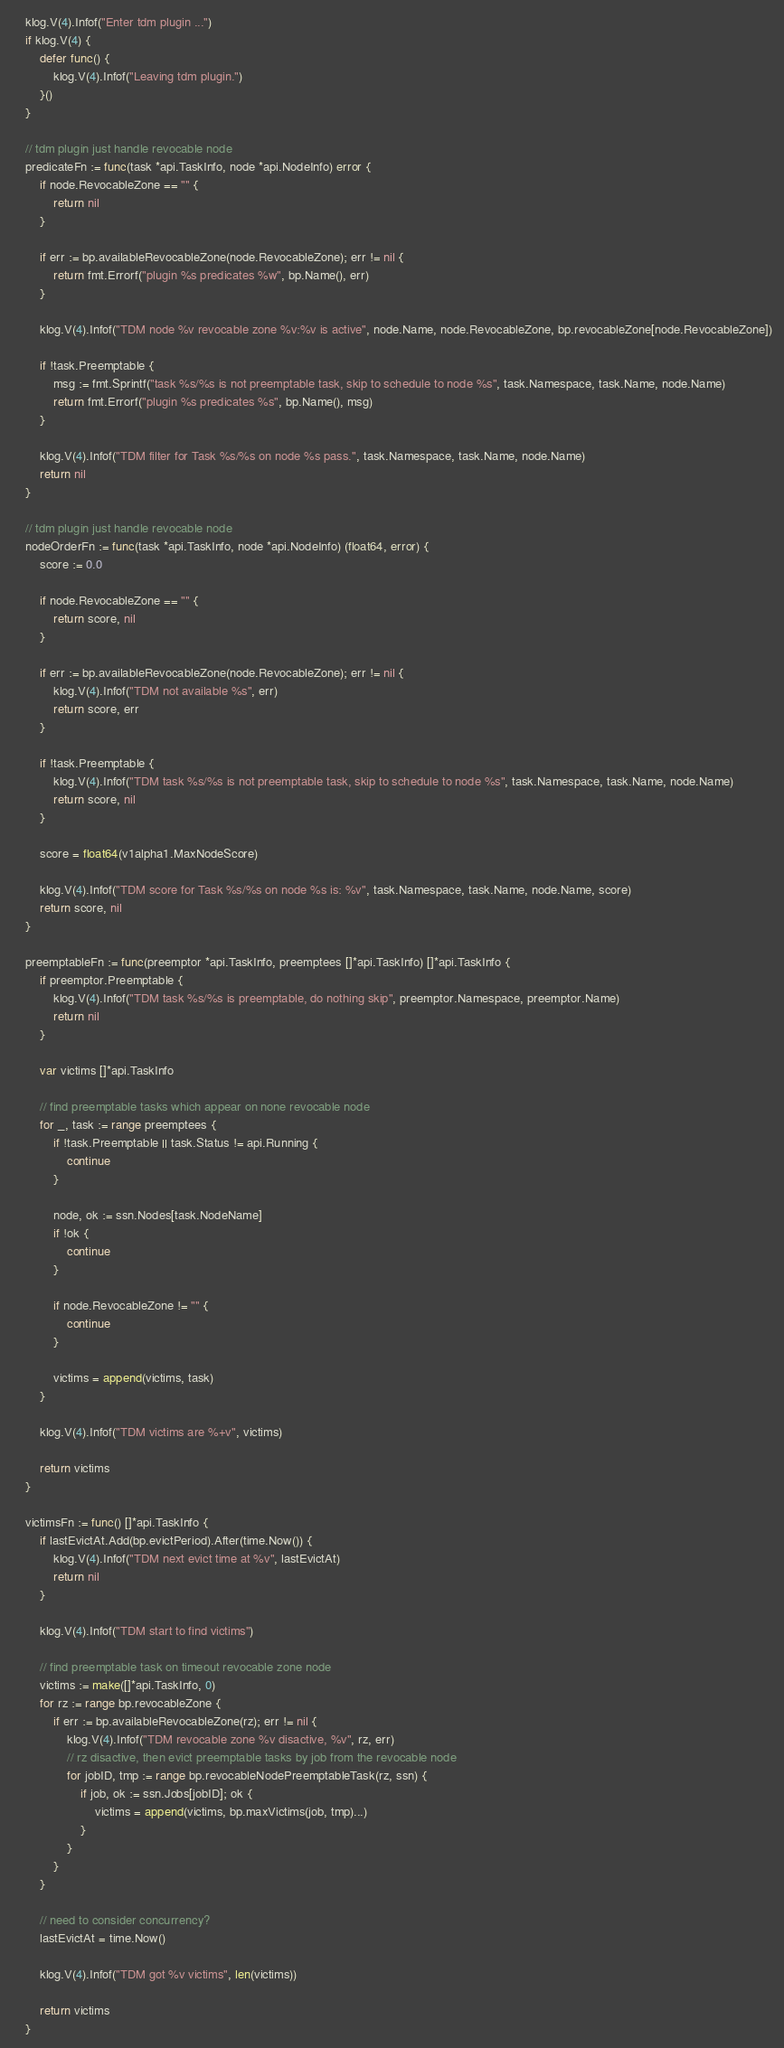Convert code to text. <code><loc_0><loc_0><loc_500><loc_500><_Go_>	klog.V(4).Infof("Enter tdm plugin ...")
	if klog.V(4) {
		defer func() {
			klog.V(4).Infof("Leaving tdm plugin.")
		}()
	}

	// tdm plugin just handle revocable node
	predicateFn := func(task *api.TaskInfo, node *api.NodeInfo) error {
		if node.RevocableZone == "" {
			return nil
		}

		if err := bp.availableRevocableZone(node.RevocableZone); err != nil {
			return fmt.Errorf("plugin %s predicates %w", bp.Name(), err)
		}

		klog.V(4).Infof("TDM node %v revocable zone %v:%v is active", node.Name, node.RevocableZone, bp.revocableZone[node.RevocableZone])

		if !task.Preemptable {
			msg := fmt.Sprintf("task %s/%s is not preemptable task, skip to schedule to node %s", task.Namespace, task.Name, node.Name)
			return fmt.Errorf("plugin %s predicates %s", bp.Name(), msg)
		}

		klog.V(4).Infof("TDM filter for Task %s/%s on node %s pass.", task.Namespace, task.Name, node.Name)
		return nil
	}

	// tdm plugin just handle revocable node
	nodeOrderFn := func(task *api.TaskInfo, node *api.NodeInfo) (float64, error) {
		score := 0.0

		if node.RevocableZone == "" {
			return score, nil
		}

		if err := bp.availableRevocableZone(node.RevocableZone); err != nil {
			klog.V(4).Infof("TDM not available %s", err)
			return score, err
		}

		if !task.Preemptable {
			klog.V(4).Infof("TDM task %s/%s is not preemptable task, skip to schedule to node %s", task.Namespace, task.Name, node.Name)
			return score, nil
		}

		score = float64(v1alpha1.MaxNodeScore)

		klog.V(4).Infof("TDM score for Task %s/%s on node %s is: %v", task.Namespace, task.Name, node.Name, score)
		return score, nil
	}

	preemptableFn := func(preemptor *api.TaskInfo, preemptees []*api.TaskInfo) []*api.TaskInfo {
		if preemptor.Preemptable {
			klog.V(4).Infof("TDM task %s/%s is preemptable, do nothing skip", preemptor.Namespace, preemptor.Name)
			return nil
		}

		var victims []*api.TaskInfo

		// find preemptable tasks which appear on none revocable node
		for _, task := range preemptees {
			if !task.Preemptable || task.Status != api.Running {
				continue
			}

			node, ok := ssn.Nodes[task.NodeName]
			if !ok {
				continue
			}

			if node.RevocableZone != "" {
				continue
			}

			victims = append(victims, task)
		}

		klog.V(4).Infof("TDM victims are %+v", victims)

		return victims
	}

	victimsFn := func() []*api.TaskInfo {
		if lastEvictAt.Add(bp.evictPeriod).After(time.Now()) {
			klog.V(4).Infof("TDM next evict time at %v", lastEvictAt)
			return nil
		}

		klog.V(4).Infof("TDM start to find victims")

		// find preemptable task on timeout revocable zone node
		victims := make([]*api.TaskInfo, 0)
		for rz := range bp.revocableZone {
			if err := bp.availableRevocableZone(rz); err != nil {
				klog.V(4).Infof("TDM revocable zone %v disactive, %v", rz, err)
				// rz disactive, then evict preemptable tasks by job from the revocable node
				for jobID, tmp := range bp.revocableNodePreemptableTask(rz, ssn) {
					if job, ok := ssn.Jobs[jobID]; ok {
						victims = append(victims, bp.maxVictims(job, tmp)...)
					}
				}
			}
		}

		// need to consider concurrency?
		lastEvictAt = time.Now()

		klog.V(4).Infof("TDM got %v victims", len(victims))

		return victims
	}
</code> 